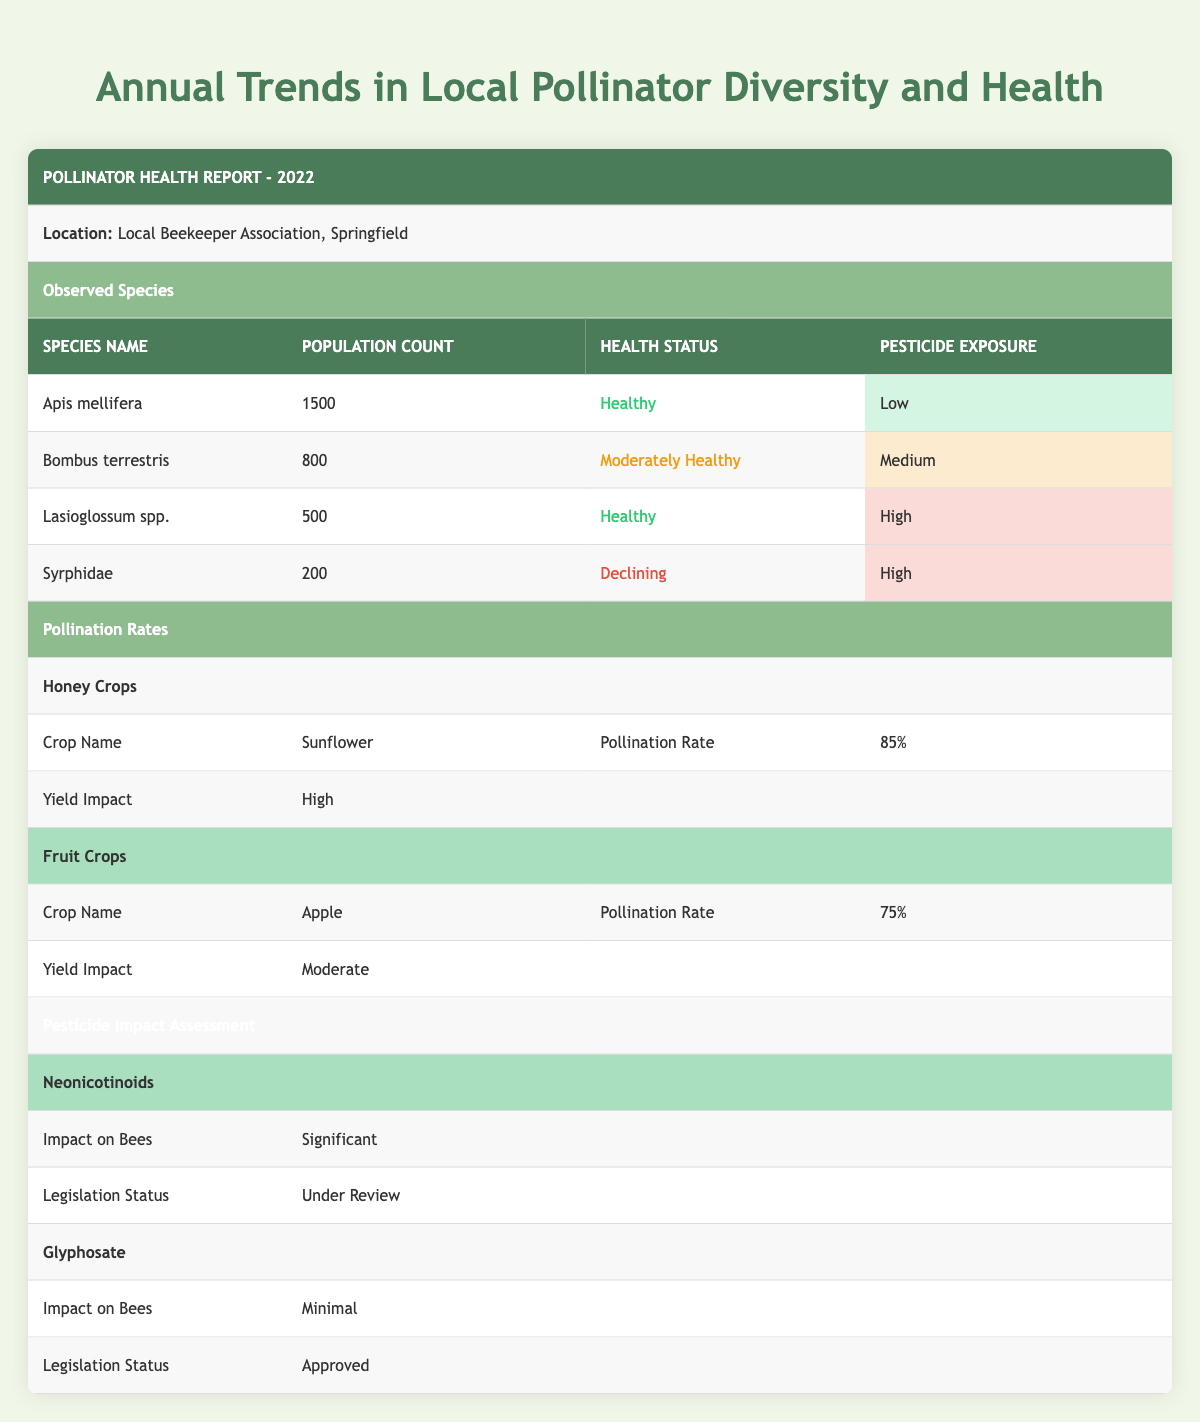What is the population count of Apis mellifera? The population count can be found directly under the row for Apis mellifera, which lists 1500 individuals.
Answer: 1500 What is the health status of Syrphidae? Syrphidae's health status is indicated in the corresponding row, where it is marked as 'Declining'.
Answer: Declining How many species have a health status of 'Healthy'? By checking each species' health status, we find that both Apis mellifera and Lasioglossum spp. are marked as 'Healthy', giving a total of 2 species.
Answer: 2 Is the impact of neonicotinoids on bees significant? The table clearly states that the impact of neonicotinoids is 'Significant'.
Answer: Yes What is the average population count of the observed species? The total population count is calculated as 1500 + 800 + 500 + 200 = 3000. To find the average, we divide this sum by the number of species (4), resulting in 3000 / 4 = 750.
Answer: 750 Which species has the highest pesticide exposure and what is their health status? Among the observed species, both Lasioglossum spp. and Syrphidae have 'High' pesticide exposure, but Syrphidae has a health status of 'Declining', while Lasioglossum spp. is 'Healthy'. Thus, Syrphidae, which has the highest exposure, is noted as 'Declining'.
Answer: Syrphidae, Declining What is the pollination rate of apple crops? Referencing the section on fruit crops, the pollination rate for apple crops is indicated as '75%'.
Answer: 75% Are there any species listed with 'Moderate' health status? Checking the health statuses of all species, Bombus terrestris is noted to be 'Moderately Healthy'.
Answer: Yes How does the yield impact of sunflower crops compare to apple crops? The yield impact of sunflower crops is categorized as 'High' while apple crops have a 'Moderate' impact. This comparison shows that the sunflower crops have a higher yield impact than apple crops.
Answer: Higher for sunflower crops 